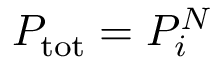<formula> <loc_0><loc_0><loc_500><loc_500>P _ { t o t } = P _ { i } ^ { N }</formula> 